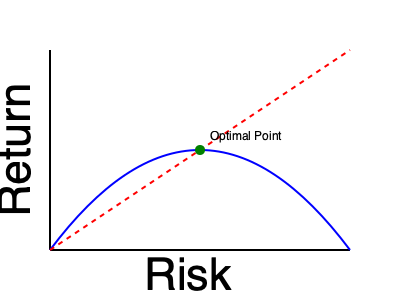In the graph above, which represents the relationship between risk and return in investments, what does the optimal point (green dot) correspond to in terms of a tennis shot angle? To answer this question, we need to draw parallels between investment strategy and tennis shot selection:

1. The x-axis represents risk in investments, which can be likened to the difficulty or risk of a tennis shot.
2. The y-axis represents return in investments, which can be compared to the potential reward or effectiveness of a tennis shot.
3. The blue curve shows the risk-return relationship, similar to how different shot angles in tennis offer varying levels of risk and reward.
4. The red dashed line represents the theoretical maximum return for a given risk level, analogous to the perfect shot trajectory in tennis.
5. The optimal point (green dot) is where the blue curve is closest to the red line, maximizing return for a given level of risk.

In tennis terms, this optimal point would represent:

- A shot angle that balances risk and reward
- Not too safe (low risk, low return) or too aggressive (high risk, high return)
- The angle that offers the best chance of winning the point without excessive risk

This is similar to a shot that is placed deep in the court, near the baseline, with moderate pace and spin. It's challenging for the opponent to return but not so aggressive that it's likely to result in an unforced error.
Answer: Balanced shot angle with moderate depth and pace 